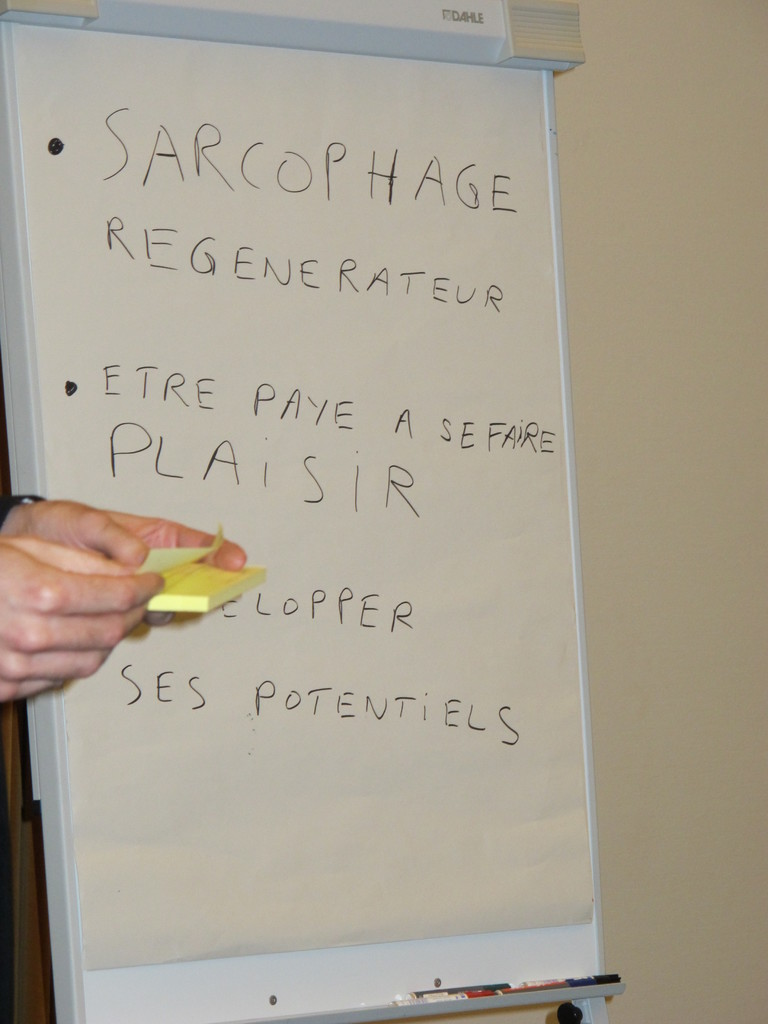Can you describe the main features of this image for me? The image features a whiteboard with several phrases written in French. These include 'SARCOPHAGE REGENERATEUR', 'ETRE PAYE A SE FAIRE PLAISIR', and 'DEVELOPPER SES POTENTIELS', which translate to 'Regenerating Sarcophagus', 'Being paid to have fun', and 'Developing one's potentials' respectively. This suggests an environment focused on brainstorming, likely in a creative or strategic planning setting. A person's hand is visible, holding a yellow sticky note, indicating an active session of idea posting or note-taking. The overall atmosphere implies a collaborative and possibly educational or professional scenario where these big ideas are being discussed. 